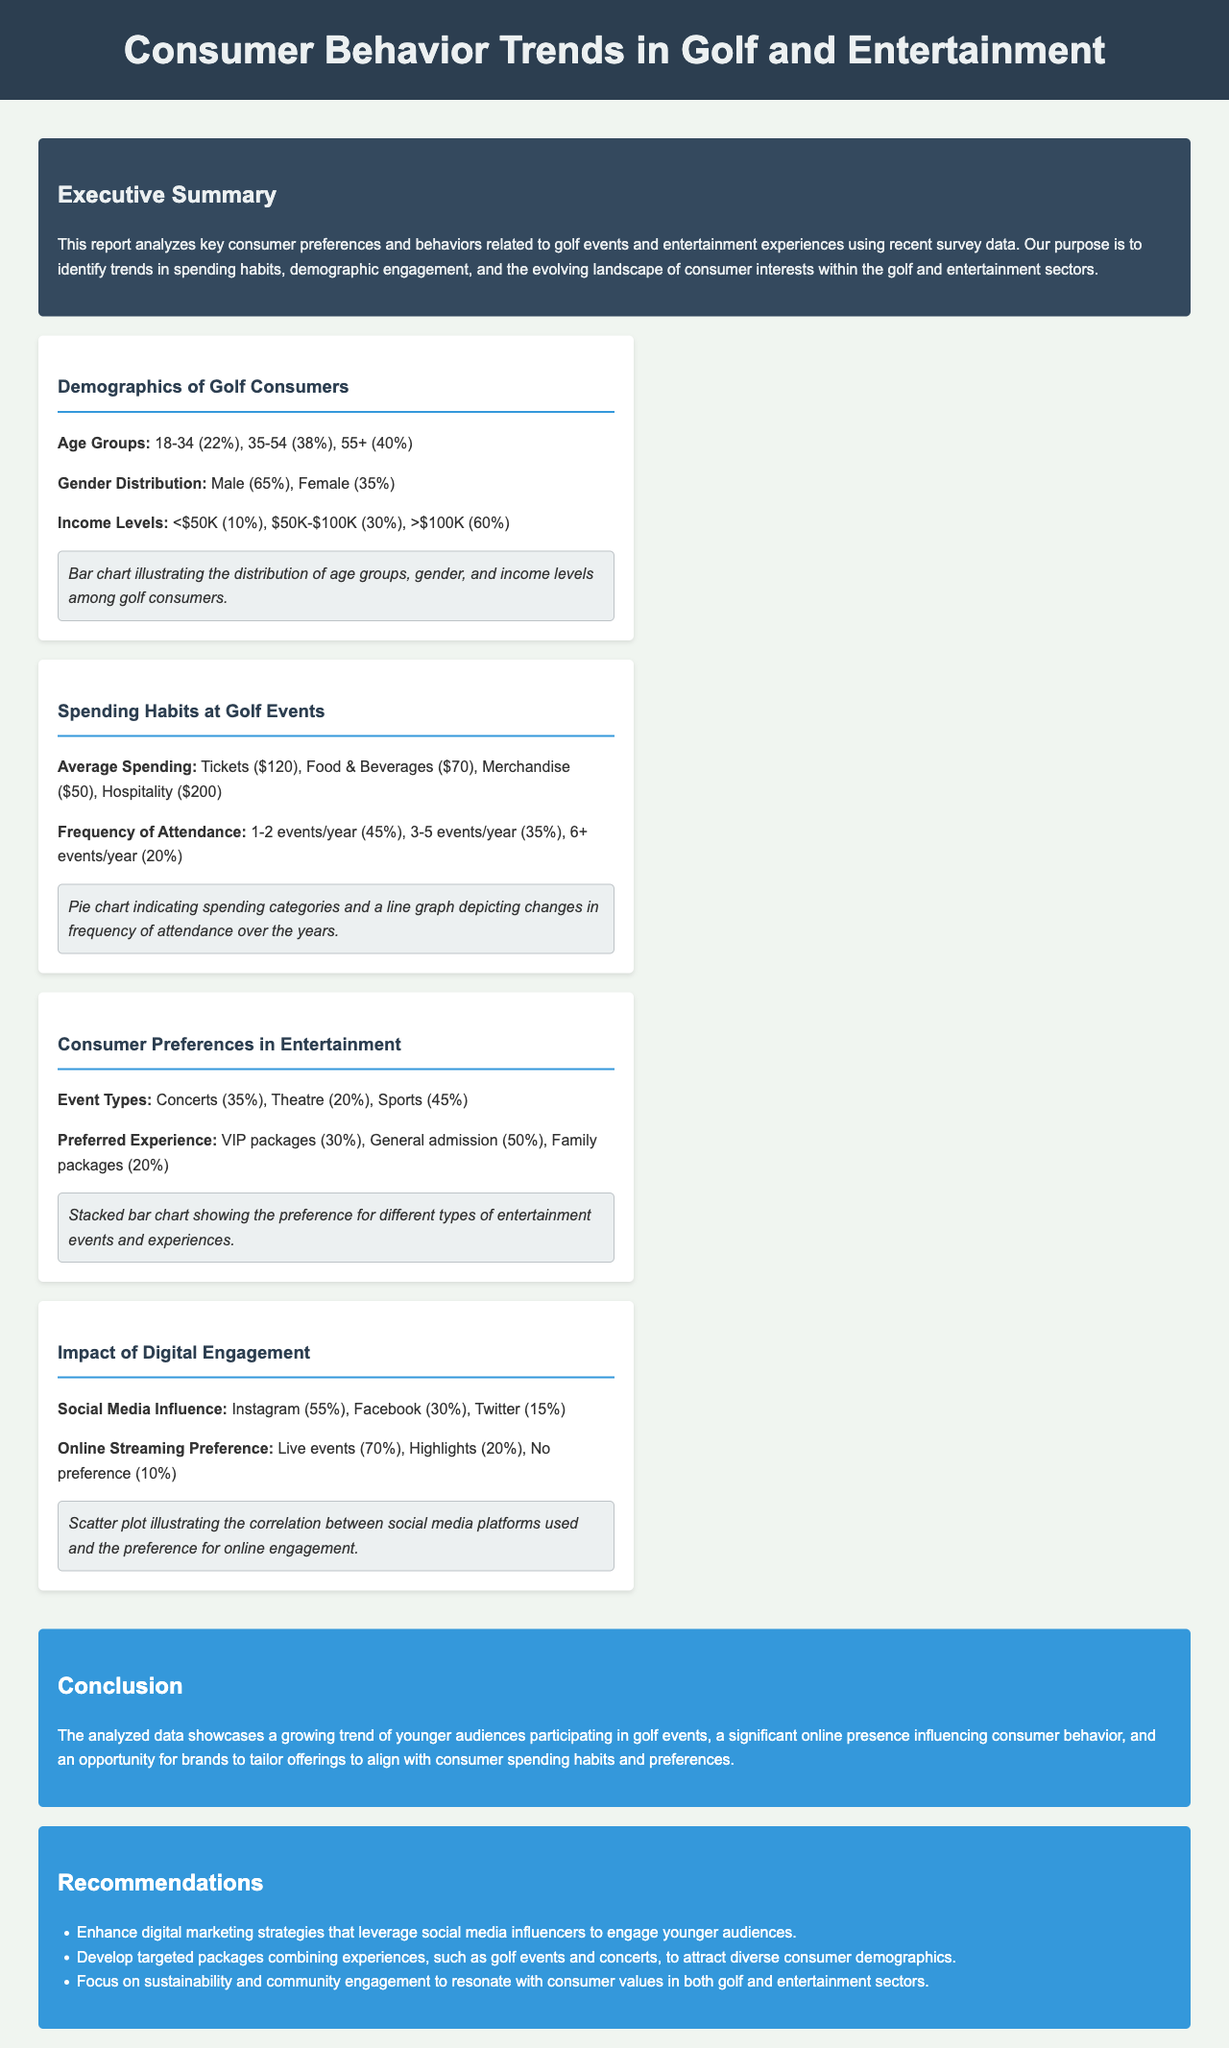What is the age group with the highest percentage among golf consumers? The age group with the highest percentage is 55+, which represents 40% of the demographic.
Answer: 55+ What percentage of golf consumers is female? The document states that female consumers make up 35% of the demographic.
Answer: 35% What is the average spending on hospitality at golf events? The average spending on hospitality is listed as $200.
Answer: $200 What is the preferred type of experience for 50% of consumers in entertainment? The preferred type of experience for 50% of consumers is general admission.
Answer: General admission Which social media platform influences consumer behavior the most according to the report? According to the report, Instagram is the most influential social media platform, cited by 55% of respondents.
Answer: Instagram How often do 45% of respondents attend golf events per year? The report indicates that 45% of respondents attend 1-2 events per year.
Answer: 1-2 events/year What are the income levels for the least represented group among golf consumers? The income level for the least represented group is those earning less than $50K, which is 10%.
Answer: Less than $50K What is the percentage of consumers who prefer online streaming of live events? The percentage of consumers who prefer online streaming of live events is 70%.
Answer: 70% How many key findings are presented in the report? The report contains four key findings relevant to consumer behavior in golf and entertainment.
Answer: Four 